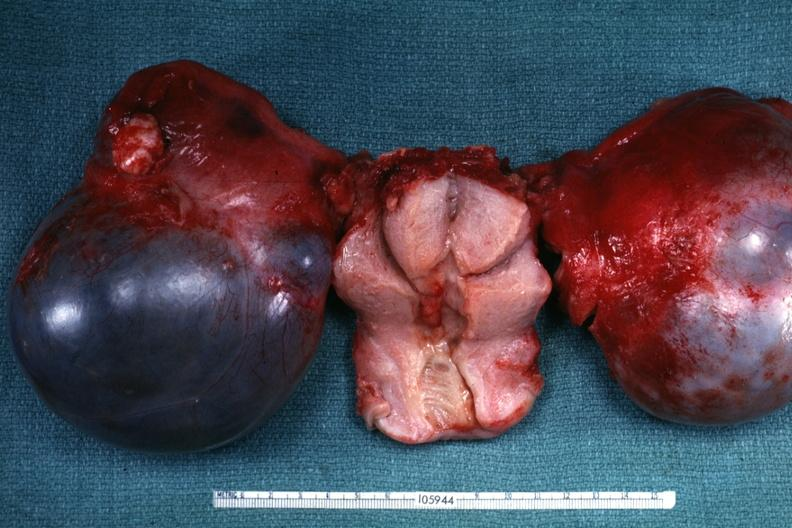where does this belong to?
Answer the question using a single word or phrase. Female reproductive system 